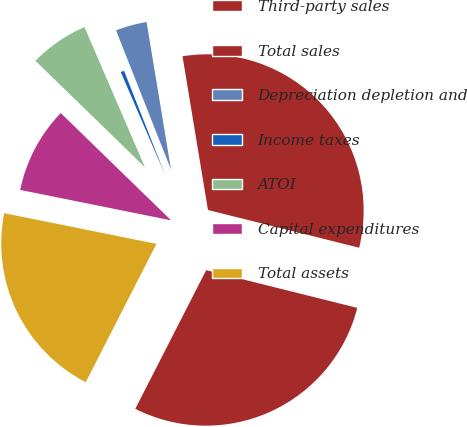Convert chart. <chart><loc_0><loc_0><loc_500><loc_500><pie_chart><fcel>Third-party sales<fcel>Total sales<fcel>Depreciation depletion and<fcel>Income taxes<fcel>ATOI<fcel>Capital expenditures<fcel>Total assets<nl><fcel>28.63%<fcel>31.5%<fcel>3.37%<fcel>0.5%<fcel>6.24%<fcel>9.11%<fcel>20.64%<nl></chart> 